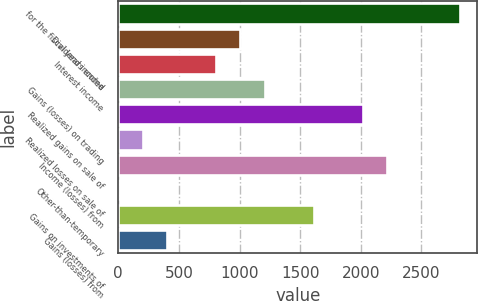<chart> <loc_0><loc_0><loc_500><loc_500><bar_chart><fcel>for the fiscal years ended<fcel>Dividend income<fcel>Interest income<fcel>Gains (losses) on trading<fcel>Realized gains on sale of<fcel>Realized losses on sale of<fcel>Income (losses) from<fcel>Other-than-temporary<fcel>Gains on investments of<fcel>Gains (losses) from<nl><fcel>2819.36<fcel>1007.3<fcel>805.96<fcel>1208.64<fcel>2014<fcel>201.94<fcel>2215.34<fcel>0.6<fcel>1611.32<fcel>403.28<nl></chart> 